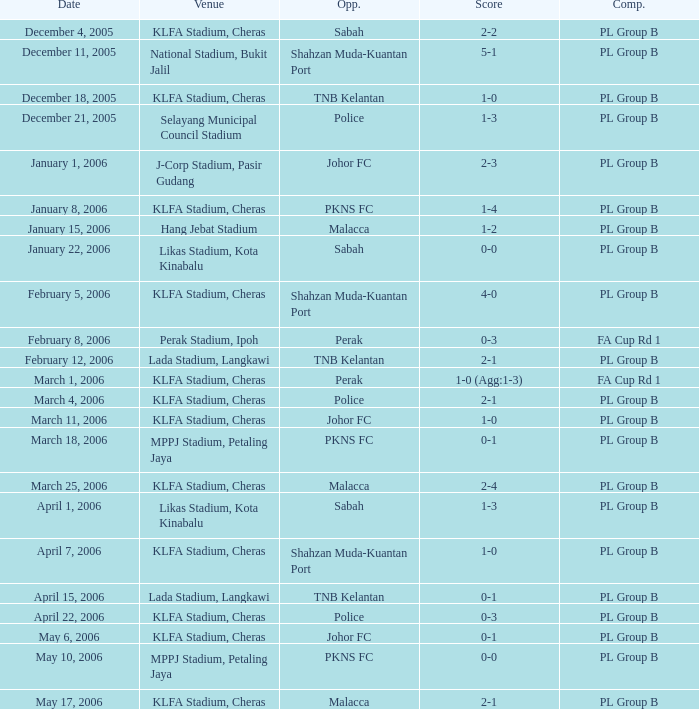Who competed on may 6, 2006? Johor FC. 